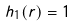<formula> <loc_0><loc_0><loc_500><loc_500>h _ { 1 } ( r ) = 1</formula> 